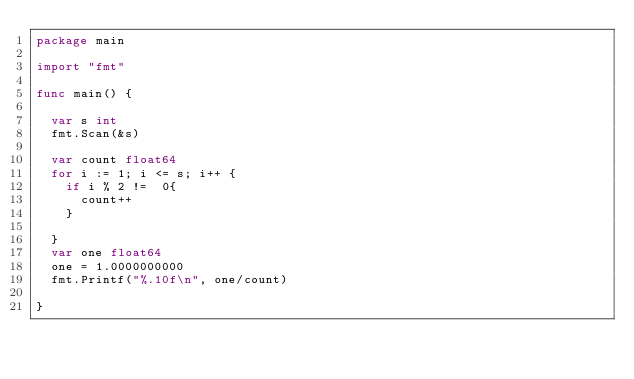<code> <loc_0><loc_0><loc_500><loc_500><_Go_>package main

import "fmt"

func main() {

	var s int
	fmt.Scan(&s)

	var count float64
	for i := 1; i <= s; i++ {
		if i % 2 !=  0{
			count++
		}

	}
	var one float64
	one = 1.0000000000
	fmt.Printf("%.10f\n", one/count)

}
</code> 